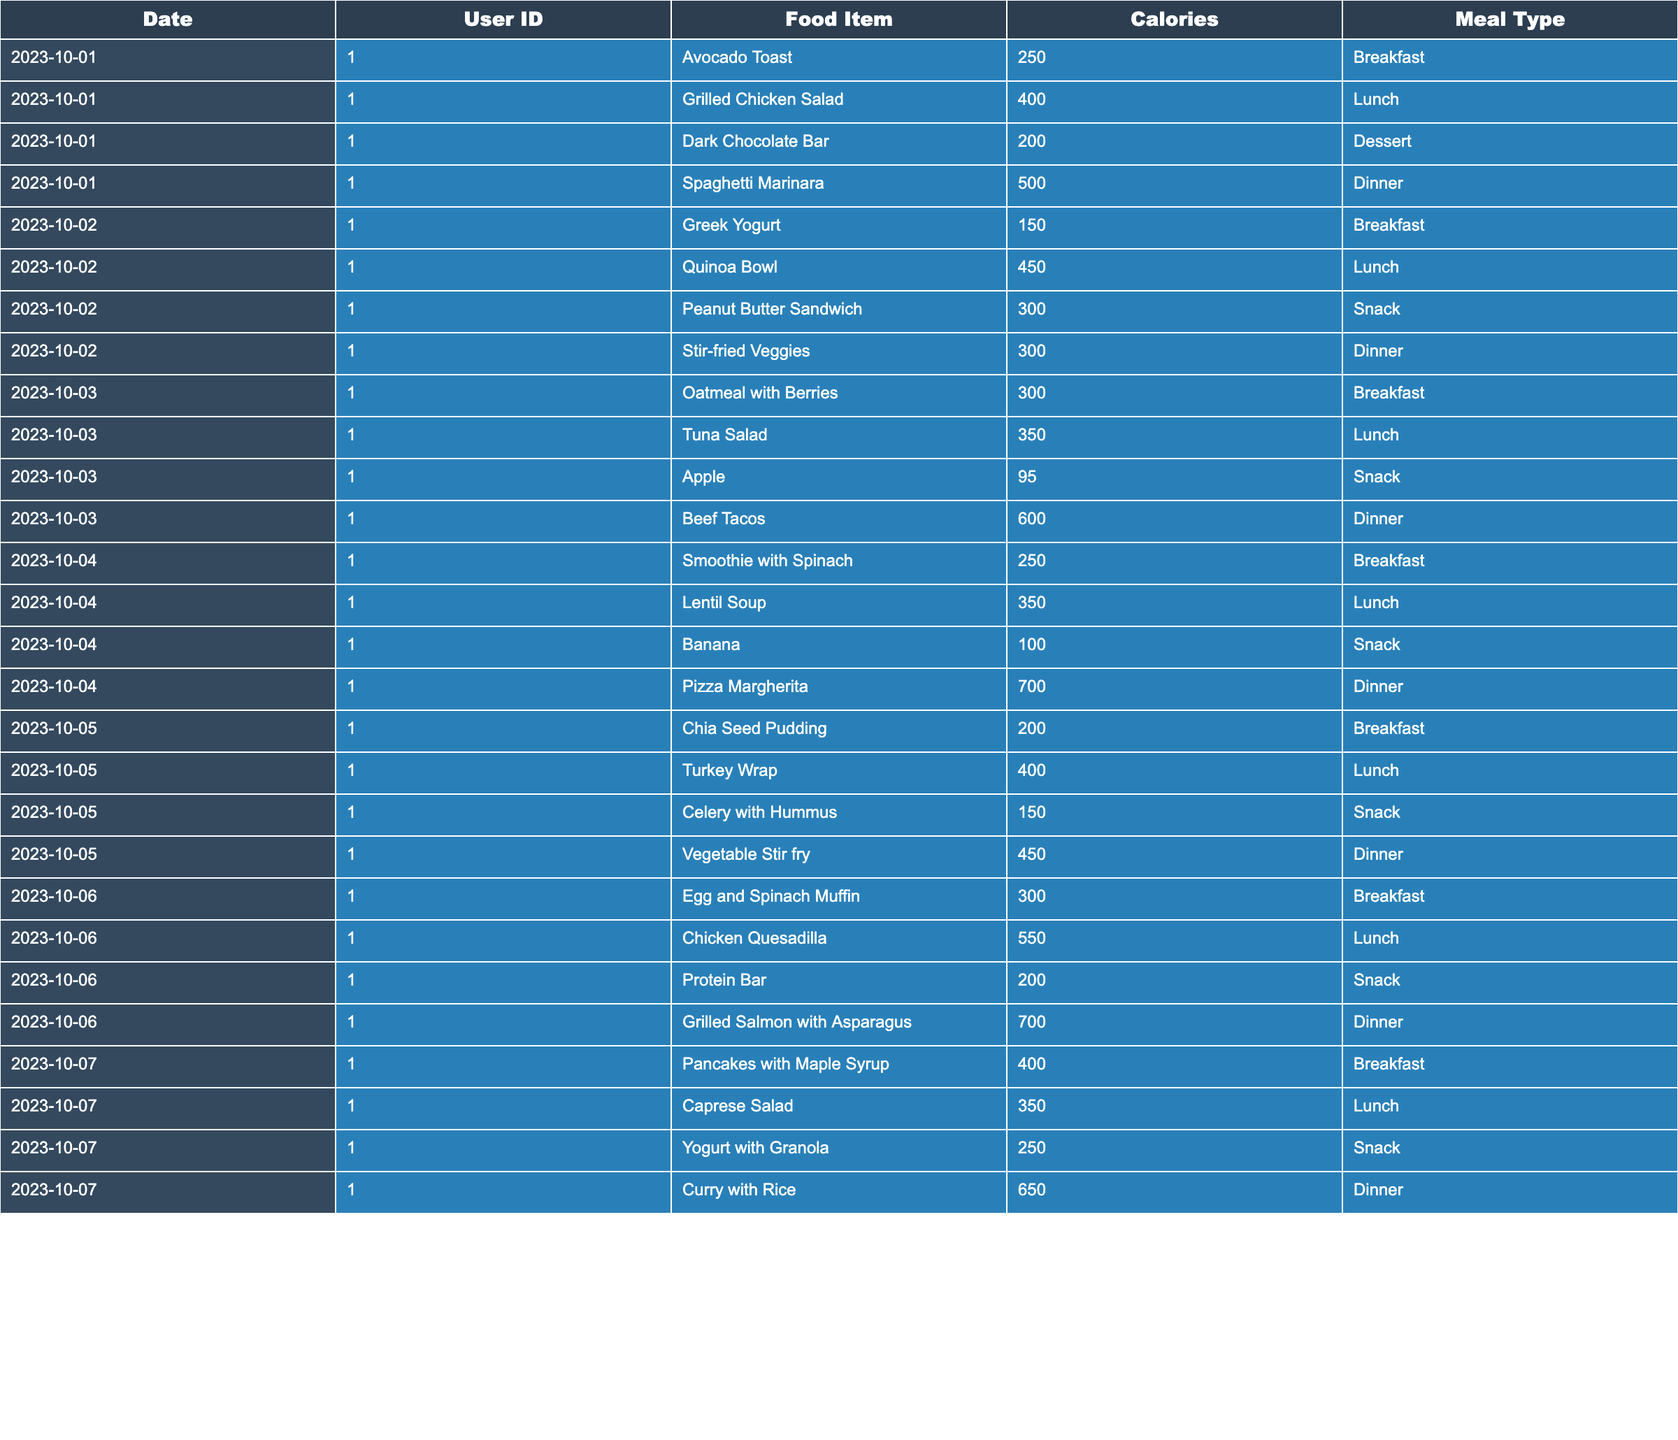What food item had the highest caloric content for dinner? The food item with the highest calories during dinner is "Pizza Margherita," which has 700 calories on October 4th, as shown in the dinner section of the table.
Answer: Pizza Margherita What was the total caloric intake for October 1st? To find the total caloric intake for October 1st, we add the calories of all meals: 250 (Breakfast) + 400 (Lunch) + 200 (Dessert) + 500 (Dinner) = 1350 calories.
Answer: 1350 Did the user consume a snack on October 6th? Yes, the user had a snack on October 6th, which was a "Protein Bar" containing 200 calories, confirming that a snack was consumed.
Answer: Yes What is the average caloric intake per day for the user over the 7 days? The total caloric intake over the 7 days is calculated from each day's totals, giving us a sum of 8125 calories across 7 days. Dividing by 7 results in an average of 1160.71 calories per day.
Answer: 1160.71 Which meal type contributed the most calories on October 4th? On October 4th, the dinner meal, which was "Pizza Margherita" with 700 calories, had the highest caloric contribution compared to other meals that day.
Answer: Dinner How many meals had more than 600 calories during the tracking period? By reviewing the table, we identify three meals with more than 600 calories: "Beef Tacos" (600), "Pizza Margherita" (700), and "Grilled Salmon with Asparagus" (700). Therefore, there are three meals over 600 calories.
Answer: 3 Was there any day when the user consumed exactly 450 calories for lunch? Yes, on October 2nd, the user had a "Quinoa Bowl" that contained exactly 450 calories for lunch, confirming that there was a day with this caloric intake.
Answer: Yes What is the total caloric intake from snacks across all days? The snacks across all days total: 200 (October 1st) + 300 (October 2nd) + 95 (October 3rd) + 100 (October 4th) + 150 (October 5th) + 200 (October 6th) + 250 (October 7th) = 1295 calories in snacks.
Answer: 1295 